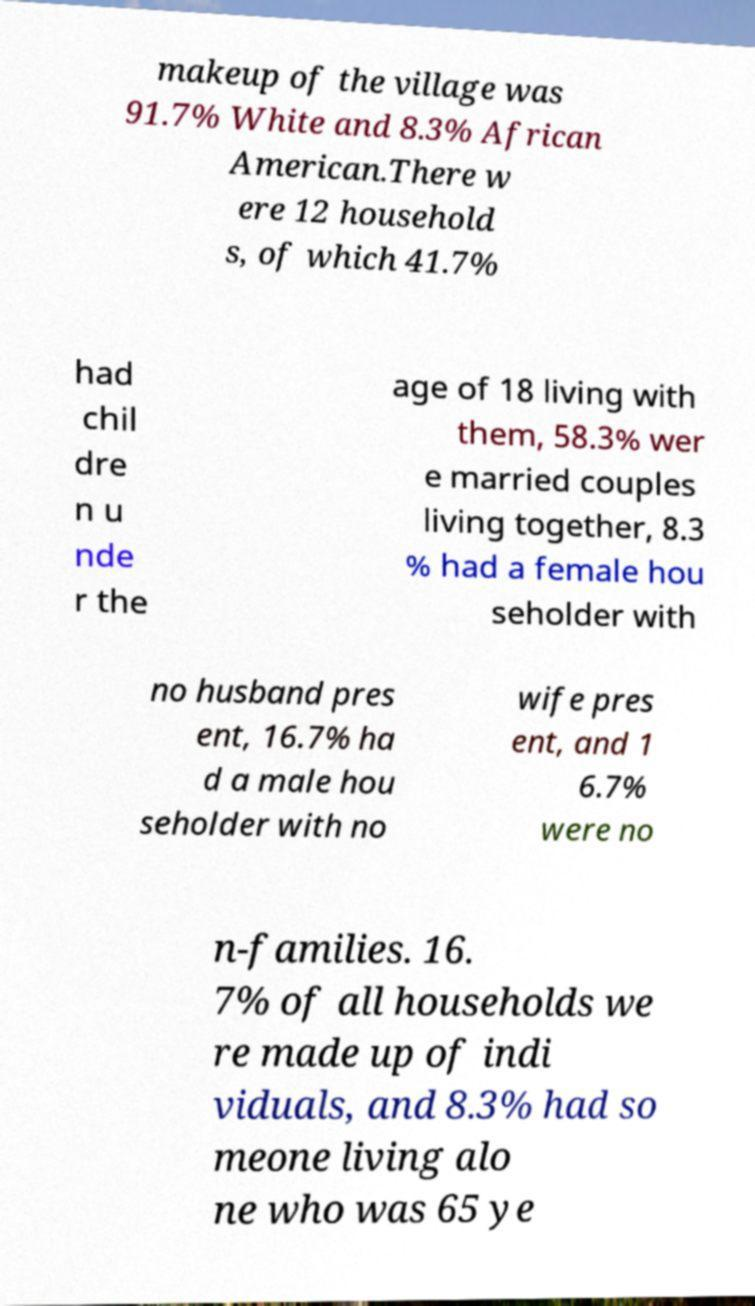For documentation purposes, I need the text within this image transcribed. Could you provide that? makeup of the village was 91.7% White and 8.3% African American.There w ere 12 household s, of which 41.7% had chil dre n u nde r the age of 18 living with them, 58.3% wer e married couples living together, 8.3 % had a female hou seholder with no husband pres ent, 16.7% ha d a male hou seholder with no wife pres ent, and 1 6.7% were no n-families. 16. 7% of all households we re made up of indi viduals, and 8.3% had so meone living alo ne who was 65 ye 